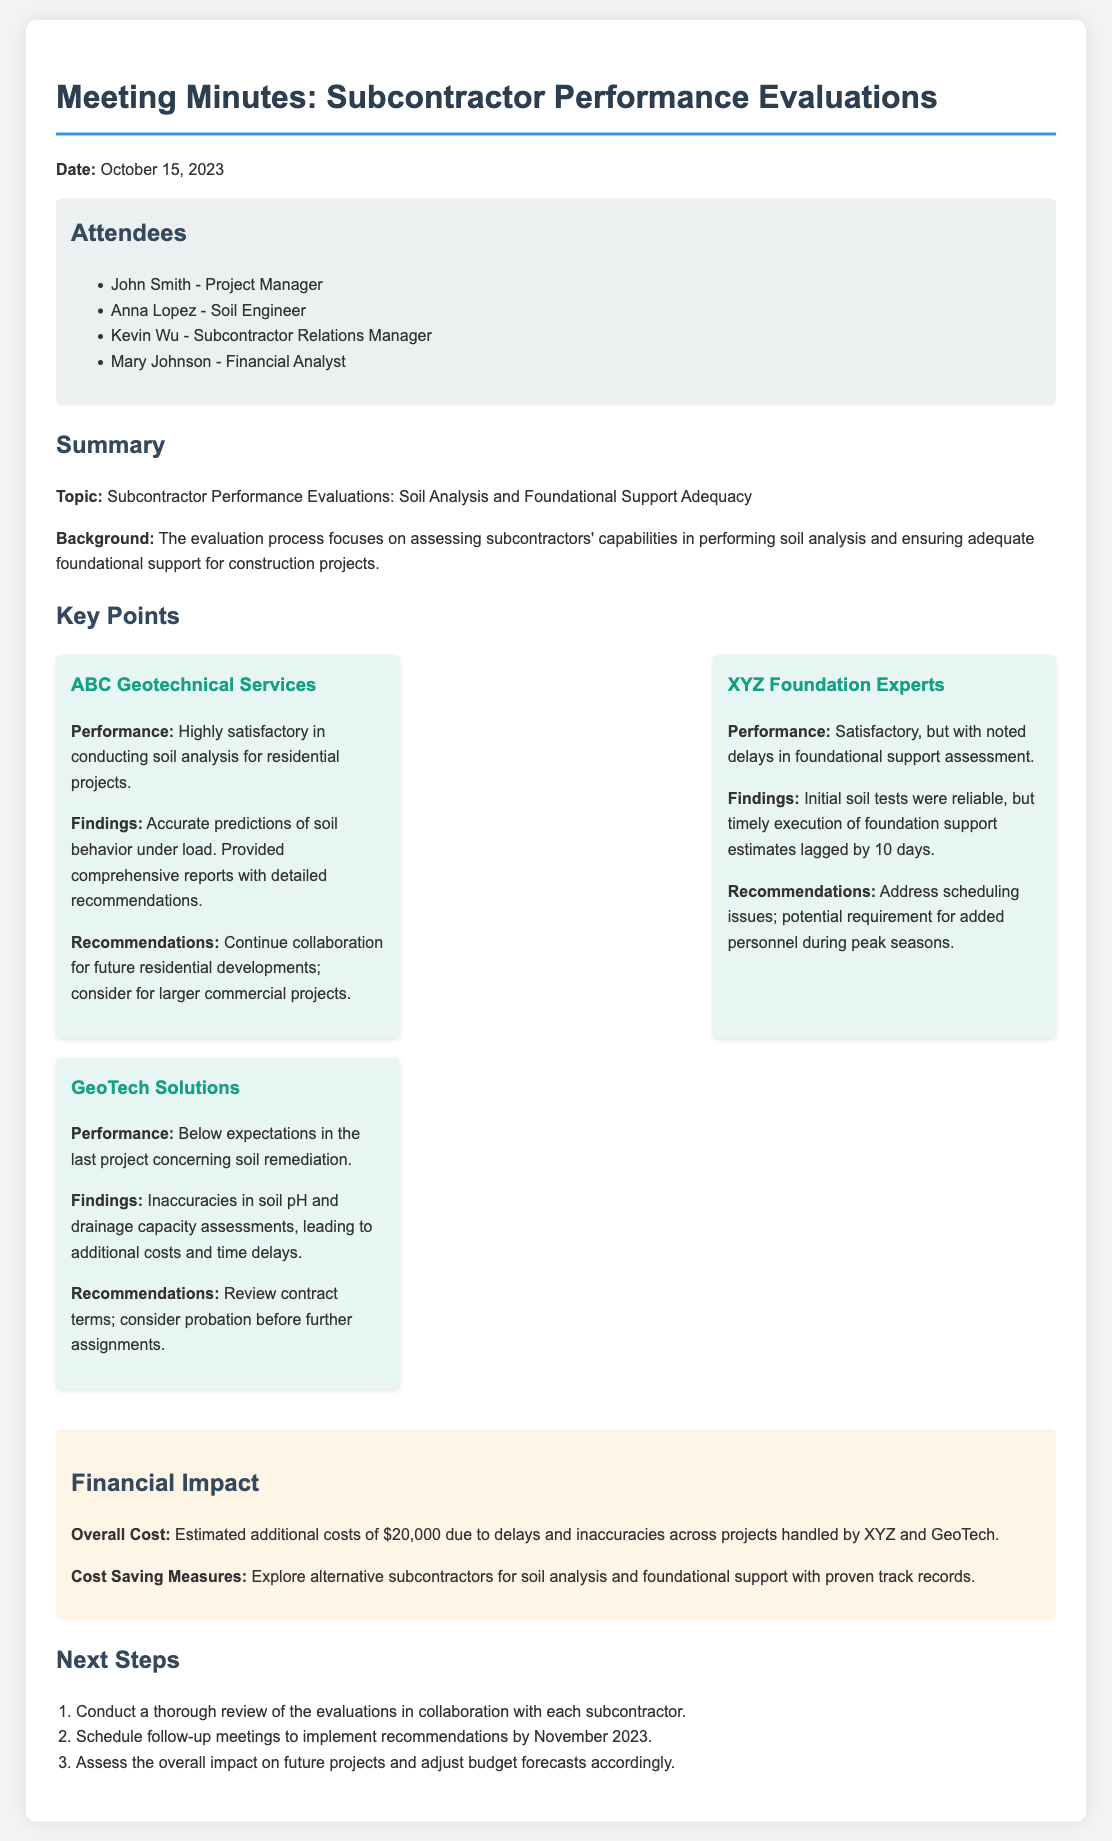What is the date of the meeting? The date of the meeting is specified at the beginning of the document.
Answer: October 15, 2023 Who is the Soil Engineer in the meeting? The attendees list includes the names and roles of participants; Anna Lopez is the Soil Engineer.
Answer: Anna Lopez What was the performance rating of ABC Geotechnical Services? Performance ratings for subcontractors are provided in the key points section; ABC Geotechnical Services is rated highly satisfactory.
Answer: Highly satisfactory How many days was XYZ Foundation Experts' foundational support assessment delayed? The key points section provides information about delays; the delay noted is 10 days.
Answer: 10 days What was the estimated additional cost due to delays and inaccuracies? The financial impact section summarizes additional costs across projects; the estimated additional cost is $20,000.
Answer: $20,000 What are the recommendations for GeoTech Solutions? The key points section specifies recommendations based on performance, indicating a review of contract terms and consideration for probation.
Answer: Review contract terms; consider probation What is one of the next steps mentioned in the document? The next steps section lists actions to be taken following the meeting; conducting a thorough review is mentioned as a step.
Answer: Conduct a thorough review What is the primary topic of the meeting? The summary introduces the topic that the meeting focused on; it relates to subcontractor performance evaluations.
Answer: Subcontractor Performance Evaluations: Soil Analysis and Foundational Support Adequacy 